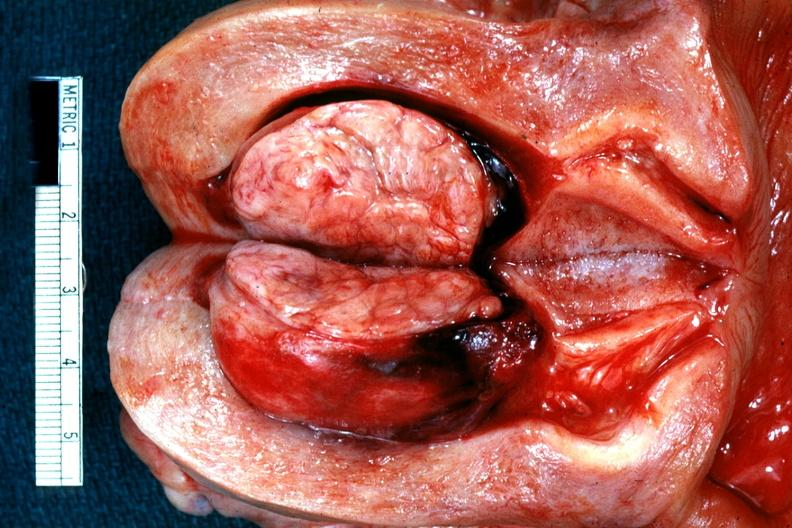s leiomyoma present?
Answer the question using a single word or phrase. Yes 